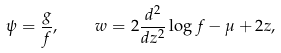Convert formula to latex. <formula><loc_0><loc_0><loc_500><loc_500>\psi = \frac { g } { f } , \quad w = 2 \frac { d ^ { 2 } } { d z ^ { 2 } } \log f - \mu + 2 z ,</formula> 